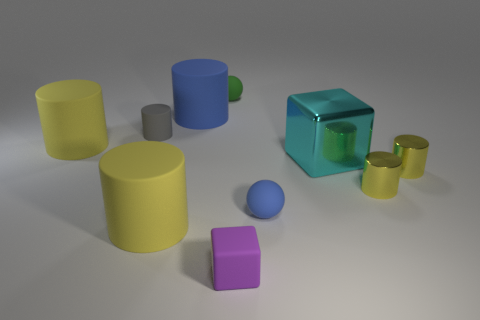How might lighting influence the appearance of colors in this collection of objects? Lighting plays a crucial role in the perception of color. The soft, diffused lighting in the image brings out the vibrancy of the objects' colors without creating harsh shadows, making each hue appear more vivid and true to life. 